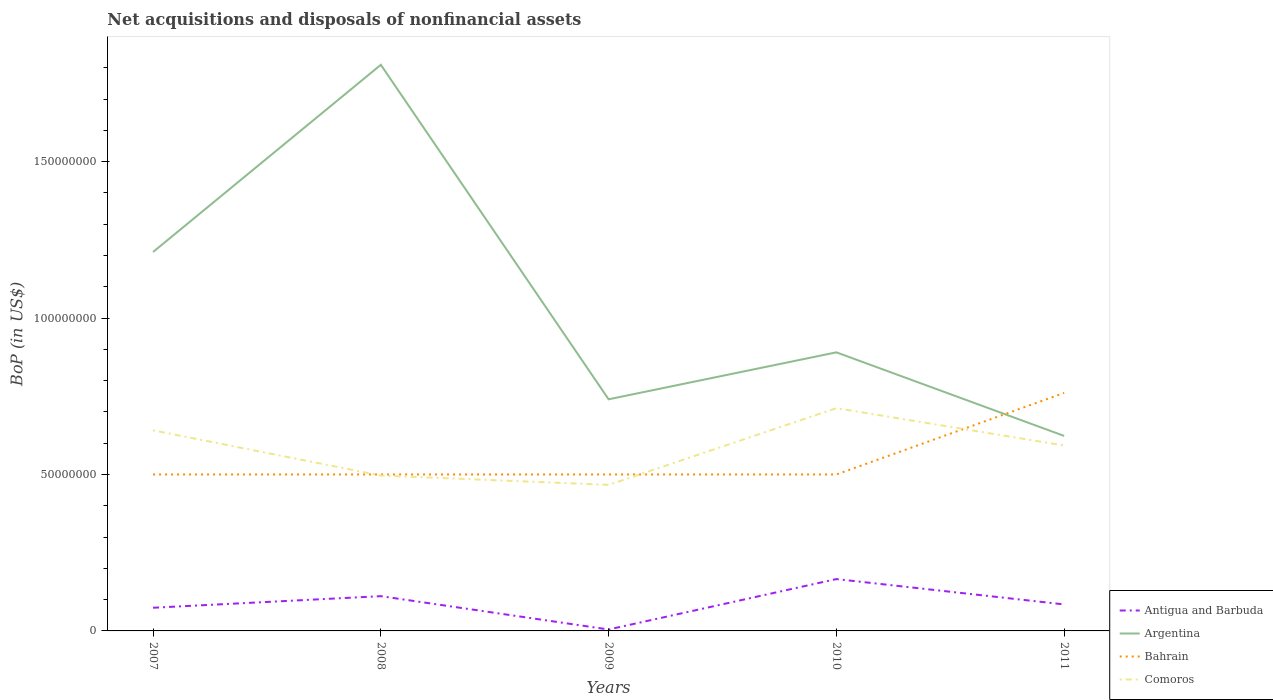How many different coloured lines are there?
Offer a terse response. 4. Does the line corresponding to Bahrain intersect with the line corresponding to Antigua and Barbuda?
Make the answer very short. No. Across all years, what is the maximum Balance of Payments in Comoros?
Keep it short and to the point. 4.67e+07. What is the total Balance of Payments in Argentina in the graph?
Keep it short and to the point. 3.21e+07. What is the difference between the highest and the second highest Balance of Payments in Bahrain?
Offer a terse response. 2.61e+07. Is the Balance of Payments in Antigua and Barbuda strictly greater than the Balance of Payments in Comoros over the years?
Ensure brevity in your answer.  Yes. How many lines are there?
Ensure brevity in your answer.  4. Are the values on the major ticks of Y-axis written in scientific E-notation?
Ensure brevity in your answer.  No. Does the graph contain any zero values?
Provide a short and direct response. No. Where does the legend appear in the graph?
Your answer should be compact. Bottom right. What is the title of the graph?
Offer a very short reply. Net acquisitions and disposals of nonfinancial assets. Does "Lao PDR" appear as one of the legend labels in the graph?
Your answer should be compact. No. What is the label or title of the X-axis?
Your response must be concise. Years. What is the label or title of the Y-axis?
Provide a succinct answer. BoP (in US$). What is the BoP (in US$) in Antigua and Barbuda in 2007?
Keep it short and to the point. 7.41e+06. What is the BoP (in US$) in Argentina in 2007?
Offer a very short reply. 1.21e+08. What is the BoP (in US$) of Bahrain in 2007?
Ensure brevity in your answer.  5.00e+07. What is the BoP (in US$) of Comoros in 2007?
Your answer should be compact. 6.41e+07. What is the BoP (in US$) of Antigua and Barbuda in 2008?
Your answer should be compact. 1.11e+07. What is the BoP (in US$) in Argentina in 2008?
Your answer should be very brief. 1.81e+08. What is the BoP (in US$) of Bahrain in 2008?
Provide a succinct answer. 5.00e+07. What is the BoP (in US$) in Comoros in 2008?
Provide a succinct answer. 4.97e+07. What is the BoP (in US$) in Antigua and Barbuda in 2009?
Make the answer very short. 4.59e+05. What is the BoP (in US$) of Argentina in 2009?
Offer a terse response. 7.40e+07. What is the BoP (in US$) in Comoros in 2009?
Your answer should be very brief. 4.67e+07. What is the BoP (in US$) in Antigua and Barbuda in 2010?
Make the answer very short. 1.66e+07. What is the BoP (in US$) in Argentina in 2010?
Provide a succinct answer. 8.90e+07. What is the BoP (in US$) in Comoros in 2010?
Give a very brief answer. 7.12e+07. What is the BoP (in US$) in Antigua and Barbuda in 2011?
Your answer should be compact. 8.47e+06. What is the BoP (in US$) of Argentina in 2011?
Keep it short and to the point. 6.23e+07. What is the BoP (in US$) in Bahrain in 2011?
Ensure brevity in your answer.  7.61e+07. What is the BoP (in US$) of Comoros in 2011?
Your response must be concise. 5.93e+07. Across all years, what is the maximum BoP (in US$) in Antigua and Barbuda?
Your response must be concise. 1.66e+07. Across all years, what is the maximum BoP (in US$) in Argentina?
Keep it short and to the point. 1.81e+08. Across all years, what is the maximum BoP (in US$) of Bahrain?
Your response must be concise. 7.61e+07. Across all years, what is the maximum BoP (in US$) in Comoros?
Give a very brief answer. 7.12e+07. Across all years, what is the minimum BoP (in US$) of Antigua and Barbuda?
Give a very brief answer. 4.59e+05. Across all years, what is the minimum BoP (in US$) of Argentina?
Keep it short and to the point. 6.23e+07. Across all years, what is the minimum BoP (in US$) in Comoros?
Your answer should be very brief. 4.67e+07. What is the total BoP (in US$) of Antigua and Barbuda in the graph?
Offer a terse response. 4.40e+07. What is the total BoP (in US$) in Argentina in the graph?
Offer a very short reply. 5.27e+08. What is the total BoP (in US$) of Bahrain in the graph?
Your response must be concise. 2.76e+08. What is the total BoP (in US$) in Comoros in the graph?
Your response must be concise. 2.91e+08. What is the difference between the BoP (in US$) of Antigua and Barbuda in 2007 and that in 2008?
Give a very brief answer. -3.70e+06. What is the difference between the BoP (in US$) of Argentina in 2007 and that in 2008?
Ensure brevity in your answer.  -5.98e+07. What is the difference between the BoP (in US$) in Bahrain in 2007 and that in 2008?
Your answer should be very brief. 0. What is the difference between the BoP (in US$) in Comoros in 2007 and that in 2008?
Keep it short and to the point. 1.45e+07. What is the difference between the BoP (in US$) in Antigua and Barbuda in 2007 and that in 2009?
Keep it short and to the point. 6.95e+06. What is the difference between the BoP (in US$) in Argentina in 2007 and that in 2009?
Your response must be concise. 4.71e+07. What is the difference between the BoP (in US$) of Bahrain in 2007 and that in 2009?
Provide a succinct answer. 0. What is the difference between the BoP (in US$) of Comoros in 2007 and that in 2009?
Give a very brief answer. 1.74e+07. What is the difference between the BoP (in US$) of Antigua and Barbuda in 2007 and that in 2010?
Your response must be concise. -9.16e+06. What is the difference between the BoP (in US$) in Argentina in 2007 and that in 2010?
Your response must be concise. 3.21e+07. What is the difference between the BoP (in US$) of Comoros in 2007 and that in 2010?
Make the answer very short. -7.08e+06. What is the difference between the BoP (in US$) in Antigua and Barbuda in 2007 and that in 2011?
Offer a very short reply. -1.06e+06. What is the difference between the BoP (in US$) of Argentina in 2007 and that in 2011?
Ensure brevity in your answer.  5.88e+07. What is the difference between the BoP (in US$) of Bahrain in 2007 and that in 2011?
Provide a short and direct response. -2.61e+07. What is the difference between the BoP (in US$) of Comoros in 2007 and that in 2011?
Give a very brief answer. 4.85e+06. What is the difference between the BoP (in US$) of Antigua and Barbuda in 2008 and that in 2009?
Offer a terse response. 1.07e+07. What is the difference between the BoP (in US$) of Argentina in 2008 and that in 2009?
Provide a short and direct response. 1.07e+08. What is the difference between the BoP (in US$) of Bahrain in 2008 and that in 2009?
Keep it short and to the point. 0. What is the difference between the BoP (in US$) in Comoros in 2008 and that in 2009?
Provide a short and direct response. 2.97e+06. What is the difference between the BoP (in US$) of Antigua and Barbuda in 2008 and that in 2010?
Offer a very short reply. -5.46e+06. What is the difference between the BoP (in US$) in Argentina in 2008 and that in 2010?
Offer a terse response. 9.19e+07. What is the difference between the BoP (in US$) of Comoros in 2008 and that in 2010?
Keep it short and to the point. -2.15e+07. What is the difference between the BoP (in US$) in Antigua and Barbuda in 2008 and that in 2011?
Make the answer very short. 2.64e+06. What is the difference between the BoP (in US$) in Argentina in 2008 and that in 2011?
Ensure brevity in your answer.  1.19e+08. What is the difference between the BoP (in US$) in Bahrain in 2008 and that in 2011?
Ensure brevity in your answer.  -2.61e+07. What is the difference between the BoP (in US$) of Comoros in 2008 and that in 2011?
Your answer should be compact. -9.60e+06. What is the difference between the BoP (in US$) in Antigua and Barbuda in 2009 and that in 2010?
Offer a very short reply. -1.61e+07. What is the difference between the BoP (in US$) in Argentina in 2009 and that in 2010?
Provide a short and direct response. -1.50e+07. What is the difference between the BoP (in US$) of Bahrain in 2009 and that in 2010?
Provide a short and direct response. 0. What is the difference between the BoP (in US$) of Comoros in 2009 and that in 2010?
Ensure brevity in your answer.  -2.45e+07. What is the difference between the BoP (in US$) of Antigua and Barbuda in 2009 and that in 2011?
Your answer should be very brief. -8.01e+06. What is the difference between the BoP (in US$) in Argentina in 2009 and that in 2011?
Provide a succinct answer. 1.17e+07. What is the difference between the BoP (in US$) in Bahrain in 2009 and that in 2011?
Keep it short and to the point. -2.61e+07. What is the difference between the BoP (in US$) of Comoros in 2009 and that in 2011?
Provide a short and direct response. -1.26e+07. What is the difference between the BoP (in US$) in Antigua and Barbuda in 2010 and that in 2011?
Offer a very short reply. 8.10e+06. What is the difference between the BoP (in US$) of Argentina in 2010 and that in 2011?
Provide a succinct answer. 2.67e+07. What is the difference between the BoP (in US$) of Bahrain in 2010 and that in 2011?
Give a very brief answer. -2.61e+07. What is the difference between the BoP (in US$) of Comoros in 2010 and that in 2011?
Your response must be concise. 1.19e+07. What is the difference between the BoP (in US$) of Antigua and Barbuda in 2007 and the BoP (in US$) of Argentina in 2008?
Give a very brief answer. -1.74e+08. What is the difference between the BoP (in US$) in Antigua and Barbuda in 2007 and the BoP (in US$) in Bahrain in 2008?
Make the answer very short. -4.26e+07. What is the difference between the BoP (in US$) of Antigua and Barbuda in 2007 and the BoP (in US$) of Comoros in 2008?
Give a very brief answer. -4.22e+07. What is the difference between the BoP (in US$) of Argentina in 2007 and the BoP (in US$) of Bahrain in 2008?
Keep it short and to the point. 7.11e+07. What is the difference between the BoP (in US$) in Argentina in 2007 and the BoP (in US$) in Comoros in 2008?
Offer a terse response. 7.14e+07. What is the difference between the BoP (in US$) in Bahrain in 2007 and the BoP (in US$) in Comoros in 2008?
Your answer should be compact. 3.45e+05. What is the difference between the BoP (in US$) of Antigua and Barbuda in 2007 and the BoP (in US$) of Argentina in 2009?
Your answer should be compact. -6.66e+07. What is the difference between the BoP (in US$) of Antigua and Barbuda in 2007 and the BoP (in US$) of Bahrain in 2009?
Keep it short and to the point. -4.26e+07. What is the difference between the BoP (in US$) of Antigua and Barbuda in 2007 and the BoP (in US$) of Comoros in 2009?
Make the answer very short. -3.93e+07. What is the difference between the BoP (in US$) in Argentina in 2007 and the BoP (in US$) in Bahrain in 2009?
Give a very brief answer. 7.11e+07. What is the difference between the BoP (in US$) of Argentina in 2007 and the BoP (in US$) of Comoros in 2009?
Ensure brevity in your answer.  7.44e+07. What is the difference between the BoP (in US$) of Bahrain in 2007 and the BoP (in US$) of Comoros in 2009?
Make the answer very short. 3.32e+06. What is the difference between the BoP (in US$) in Antigua and Barbuda in 2007 and the BoP (in US$) in Argentina in 2010?
Provide a short and direct response. -8.16e+07. What is the difference between the BoP (in US$) in Antigua and Barbuda in 2007 and the BoP (in US$) in Bahrain in 2010?
Make the answer very short. -4.26e+07. What is the difference between the BoP (in US$) in Antigua and Barbuda in 2007 and the BoP (in US$) in Comoros in 2010?
Keep it short and to the point. -6.38e+07. What is the difference between the BoP (in US$) of Argentina in 2007 and the BoP (in US$) of Bahrain in 2010?
Provide a short and direct response. 7.11e+07. What is the difference between the BoP (in US$) in Argentina in 2007 and the BoP (in US$) in Comoros in 2010?
Keep it short and to the point. 4.99e+07. What is the difference between the BoP (in US$) in Bahrain in 2007 and the BoP (in US$) in Comoros in 2010?
Provide a succinct answer. -2.12e+07. What is the difference between the BoP (in US$) in Antigua and Barbuda in 2007 and the BoP (in US$) in Argentina in 2011?
Offer a very short reply. -5.49e+07. What is the difference between the BoP (in US$) in Antigua and Barbuda in 2007 and the BoP (in US$) in Bahrain in 2011?
Make the answer very short. -6.87e+07. What is the difference between the BoP (in US$) in Antigua and Barbuda in 2007 and the BoP (in US$) in Comoros in 2011?
Your answer should be very brief. -5.19e+07. What is the difference between the BoP (in US$) of Argentina in 2007 and the BoP (in US$) of Bahrain in 2011?
Make the answer very short. 4.50e+07. What is the difference between the BoP (in US$) of Argentina in 2007 and the BoP (in US$) of Comoros in 2011?
Provide a succinct answer. 6.18e+07. What is the difference between the BoP (in US$) in Bahrain in 2007 and the BoP (in US$) in Comoros in 2011?
Your response must be concise. -9.26e+06. What is the difference between the BoP (in US$) of Antigua and Barbuda in 2008 and the BoP (in US$) of Argentina in 2009?
Provide a short and direct response. -6.29e+07. What is the difference between the BoP (in US$) in Antigua and Barbuda in 2008 and the BoP (in US$) in Bahrain in 2009?
Provide a short and direct response. -3.89e+07. What is the difference between the BoP (in US$) of Antigua and Barbuda in 2008 and the BoP (in US$) of Comoros in 2009?
Keep it short and to the point. -3.56e+07. What is the difference between the BoP (in US$) in Argentina in 2008 and the BoP (in US$) in Bahrain in 2009?
Give a very brief answer. 1.31e+08. What is the difference between the BoP (in US$) in Argentina in 2008 and the BoP (in US$) in Comoros in 2009?
Your answer should be compact. 1.34e+08. What is the difference between the BoP (in US$) of Bahrain in 2008 and the BoP (in US$) of Comoros in 2009?
Give a very brief answer. 3.32e+06. What is the difference between the BoP (in US$) in Antigua and Barbuda in 2008 and the BoP (in US$) in Argentina in 2010?
Your response must be concise. -7.79e+07. What is the difference between the BoP (in US$) in Antigua and Barbuda in 2008 and the BoP (in US$) in Bahrain in 2010?
Offer a very short reply. -3.89e+07. What is the difference between the BoP (in US$) in Antigua and Barbuda in 2008 and the BoP (in US$) in Comoros in 2010?
Offer a terse response. -6.01e+07. What is the difference between the BoP (in US$) in Argentina in 2008 and the BoP (in US$) in Bahrain in 2010?
Offer a very short reply. 1.31e+08. What is the difference between the BoP (in US$) in Argentina in 2008 and the BoP (in US$) in Comoros in 2010?
Make the answer very short. 1.10e+08. What is the difference between the BoP (in US$) of Bahrain in 2008 and the BoP (in US$) of Comoros in 2010?
Give a very brief answer. -2.12e+07. What is the difference between the BoP (in US$) in Antigua and Barbuda in 2008 and the BoP (in US$) in Argentina in 2011?
Your response must be concise. -5.12e+07. What is the difference between the BoP (in US$) in Antigua and Barbuda in 2008 and the BoP (in US$) in Bahrain in 2011?
Make the answer very short. -6.50e+07. What is the difference between the BoP (in US$) of Antigua and Barbuda in 2008 and the BoP (in US$) of Comoros in 2011?
Give a very brief answer. -4.81e+07. What is the difference between the BoP (in US$) in Argentina in 2008 and the BoP (in US$) in Bahrain in 2011?
Provide a succinct answer. 1.05e+08. What is the difference between the BoP (in US$) of Argentina in 2008 and the BoP (in US$) of Comoros in 2011?
Give a very brief answer. 1.22e+08. What is the difference between the BoP (in US$) of Bahrain in 2008 and the BoP (in US$) of Comoros in 2011?
Keep it short and to the point. -9.26e+06. What is the difference between the BoP (in US$) of Antigua and Barbuda in 2009 and the BoP (in US$) of Argentina in 2010?
Provide a short and direct response. -8.86e+07. What is the difference between the BoP (in US$) in Antigua and Barbuda in 2009 and the BoP (in US$) in Bahrain in 2010?
Provide a succinct answer. -4.95e+07. What is the difference between the BoP (in US$) of Antigua and Barbuda in 2009 and the BoP (in US$) of Comoros in 2010?
Provide a succinct answer. -7.07e+07. What is the difference between the BoP (in US$) in Argentina in 2009 and the BoP (in US$) in Bahrain in 2010?
Give a very brief answer. 2.40e+07. What is the difference between the BoP (in US$) in Argentina in 2009 and the BoP (in US$) in Comoros in 2010?
Offer a terse response. 2.84e+06. What is the difference between the BoP (in US$) in Bahrain in 2009 and the BoP (in US$) in Comoros in 2010?
Your answer should be very brief. -2.12e+07. What is the difference between the BoP (in US$) in Antigua and Barbuda in 2009 and the BoP (in US$) in Argentina in 2011?
Provide a short and direct response. -6.19e+07. What is the difference between the BoP (in US$) of Antigua and Barbuda in 2009 and the BoP (in US$) of Bahrain in 2011?
Give a very brief answer. -7.56e+07. What is the difference between the BoP (in US$) in Antigua and Barbuda in 2009 and the BoP (in US$) in Comoros in 2011?
Your response must be concise. -5.88e+07. What is the difference between the BoP (in US$) of Argentina in 2009 and the BoP (in US$) of Bahrain in 2011?
Keep it short and to the point. -2.04e+06. What is the difference between the BoP (in US$) in Argentina in 2009 and the BoP (in US$) in Comoros in 2011?
Keep it short and to the point. 1.48e+07. What is the difference between the BoP (in US$) in Bahrain in 2009 and the BoP (in US$) in Comoros in 2011?
Your answer should be very brief. -9.26e+06. What is the difference between the BoP (in US$) in Antigua and Barbuda in 2010 and the BoP (in US$) in Argentina in 2011?
Keep it short and to the point. -4.58e+07. What is the difference between the BoP (in US$) in Antigua and Barbuda in 2010 and the BoP (in US$) in Bahrain in 2011?
Offer a very short reply. -5.95e+07. What is the difference between the BoP (in US$) in Antigua and Barbuda in 2010 and the BoP (in US$) in Comoros in 2011?
Offer a terse response. -4.27e+07. What is the difference between the BoP (in US$) in Argentina in 2010 and the BoP (in US$) in Bahrain in 2011?
Offer a terse response. 1.30e+07. What is the difference between the BoP (in US$) in Argentina in 2010 and the BoP (in US$) in Comoros in 2011?
Offer a very short reply. 2.98e+07. What is the difference between the BoP (in US$) in Bahrain in 2010 and the BoP (in US$) in Comoros in 2011?
Keep it short and to the point. -9.26e+06. What is the average BoP (in US$) in Antigua and Barbuda per year?
Offer a terse response. 8.80e+06. What is the average BoP (in US$) in Argentina per year?
Ensure brevity in your answer.  1.05e+08. What is the average BoP (in US$) of Bahrain per year?
Offer a very short reply. 5.52e+07. What is the average BoP (in US$) in Comoros per year?
Your answer should be very brief. 5.82e+07. In the year 2007, what is the difference between the BoP (in US$) of Antigua and Barbuda and BoP (in US$) of Argentina?
Offer a very short reply. -1.14e+08. In the year 2007, what is the difference between the BoP (in US$) in Antigua and Barbuda and BoP (in US$) in Bahrain?
Keep it short and to the point. -4.26e+07. In the year 2007, what is the difference between the BoP (in US$) of Antigua and Barbuda and BoP (in US$) of Comoros?
Make the answer very short. -5.67e+07. In the year 2007, what is the difference between the BoP (in US$) of Argentina and BoP (in US$) of Bahrain?
Keep it short and to the point. 7.11e+07. In the year 2007, what is the difference between the BoP (in US$) in Argentina and BoP (in US$) in Comoros?
Offer a very short reply. 5.70e+07. In the year 2007, what is the difference between the BoP (in US$) of Bahrain and BoP (in US$) of Comoros?
Ensure brevity in your answer.  -1.41e+07. In the year 2008, what is the difference between the BoP (in US$) of Antigua and Barbuda and BoP (in US$) of Argentina?
Ensure brevity in your answer.  -1.70e+08. In the year 2008, what is the difference between the BoP (in US$) in Antigua and Barbuda and BoP (in US$) in Bahrain?
Keep it short and to the point. -3.89e+07. In the year 2008, what is the difference between the BoP (in US$) in Antigua and Barbuda and BoP (in US$) in Comoros?
Provide a succinct answer. -3.85e+07. In the year 2008, what is the difference between the BoP (in US$) of Argentina and BoP (in US$) of Bahrain?
Make the answer very short. 1.31e+08. In the year 2008, what is the difference between the BoP (in US$) of Argentina and BoP (in US$) of Comoros?
Ensure brevity in your answer.  1.31e+08. In the year 2008, what is the difference between the BoP (in US$) of Bahrain and BoP (in US$) of Comoros?
Provide a short and direct response. 3.45e+05. In the year 2009, what is the difference between the BoP (in US$) in Antigua and Barbuda and BoP (in US$) in Argentina?
Offer a very short reply. -7.36e+07. In the year 2009, what is the difference between the BoP (in US$) of Antigua and Barbuda and BoP (in US$) of Bahrain?
Offer a terse response. -4.95e+07. In the year 2009, what is the difference between the BoP (in US$) in Antigua and Barbuda and BoP (in US$) in Comoros?
Ensure brevity in your answer.  -4.62e+07. In the year 2009, what is the difference between the BoP (in US$) in Argentina and BoP (in US$) in Bahrain?
Make the answer very short. 2.40e+07. In the year 2009, what is the difference between the BoP (in US$) of Argentina and BoP (in US$) of Comoros?
Keep it short and to the point. 2.73e+07. In the year 2009, what is the difference between the BoP (in US$) of Bahrain and BoP (in US$) of Comoros?
Provide a short and direct response. 3.32e+06. In the year 2010, what is the difference between the BoP (in US$) of Antigua and Barbuda and BoP (in US$) of Argentina?
Your answer should be very brief. -7.25e+07. In the year 2010, what is the difference between the BoP (in US$) of Antigua and Barbuda and BoP (in US$) of Bahrain?
Your answer should be compact. -3.34e+07. In the year 2010, what is the difference between the BoP (in US$) of Antigua and Barbuda and BoP (in US$) of Comoros?
Your response must be concise. -5.46e+07. In the year 2010, what is the difference between the BoP (in US$) in Argentina and BoP (in US$) in Bahrain?
Your answer should be very brief. 3.90e+07. In the year 2010, what is the difference between the BoP (in US$) in Argentina and BoP (in US$) in Comoros?
Your response must be concise. 1.78e+07. In the year 2010, what is the difference between the BoP (in US$) of Bahrain and BoP (in US$) of Comoros?
Provide a succinct answer. -2.12e+07. In the year 2011, what is the difference between the BoP (in US$) in Antigua and Barbuda and BoP (in US$) in Argentina?
Offer a very short reply. -5.39e+07. In the year 2011, what is the difference between the BoP (in US$) of Antigua and Barbuda and BoP (in US$) of Bahrain?
Offer a terse response. -6.76e+07. In the year 2011, what is the difference between the BoP (in US$) of Antigua and Barbuda and BoP (in US$) of Comoros?
Provide a short and direct response. -5.08e+07. In the year 2011, what is the difference between the BoP (in US$) of Argentina and BoP (in US$) of Bahrain?
Make the answer very short. -1.37e+07. In the year 2011, what is the difference between the BoP (in US$) of Argentina and BoP (in US$) of Comoros?
Your answer should be very brief. 3.06e+06. In the year 2011, what is the difference between the BoP (in US$) of Bahrain and BoP (in US$) of Comoros?
Offer a terse response. 1.68e+07. What is the ratio of the BoP (in US$) of Antigua and Barbuda in 2007 to that in 2008?
Make the answer very short. 0.67. What is the ratio of the BoP (in US$) of Argentina in 2007 to that in 2008?
Offer a very short reply. 0.67. What is the ratio of the BoP (in US$) of Comoros in 2007 to that in 2008?
Offer a terse response. 1.29. What is the ratio of the BoP (in US$) in Antigua and Barbuda in 2007 to that in 2009?
Your response must be concise. 16.13. What is the ratio of the BoP (in US$) in Argentina in 2007 to that in 2009?
Your answer should be very brief. 1.64. What is the ratio of the BoP (in US$) in Bahrain in 2007 to that in 2009?
Give a very brief answer. 1. What is the ratio of the BoP (in US$) of Comoros in 2007 to that in 2009?
Provide a succinct answer. 1.37. What is the ratio of the BoP (in US$) of Antigua and Barbuda in 2007 to that in 2010?
Provide a short and direct response. 0.45. What is the ratio of the BoP (in US$) in Argentina in 2007 to that in 2010?
Your answer should be compact. 1.36. What is the ratio of the BoP (in US$) of Bahrain in 2007 to that in 2010?
Offer a very short reply. 1. What is the ratio of the BoP (in US$) in Comoros in 2007 to that in 2010?
Keep it short and to the point. 0.9. What is the ratio of the BoP (in US$) of Antigua and Barbuda in 2007 to that in 2011?
Offer a terse response. 0.87. What is the ratio of the BoP (in US$) in Argentina in 2007 to that in 2011?
Make the answer very short. 1.94. What is the ratio of the BoP (in US$) of Bahrain in 2007 to that in 2011?
Provide a succinct answer. 0.66. What is the ratio of the BoP (in US$) of Comoros in 2007 to that in 2011?
Offer a very short reply. 1.08. What is the ratio of the BoP (in US$) of Antigua and Barbuda in 2008 to that in 2009?
Provide a succinct answer. 24.2. What is the ratio of the BoP (in US$) of Argentina in 2008 to that in 2009?
Give a very brief answer. 2.44. What is the ratio of the BoP (in US$) of Bahrain in 2008 to that in 2009?
Keep it short and to the point. 1. What is the ratio of the BoP (in US$) of Comoros in 2008 to that in 2009?
Provide a succinct answer. 1.06. What is the ratio of the BoP (in US$) of Antigua and Barbuda in 2008 to that in 2010?
Your answer should be very brief. 0.67. What is the ratio of the BoP (in US$) in Argentina in 2008 to that in 2010?
Give a very brief answer. 2.03. What is the ratio of the BoP (in US$) of Bahrain in 2008 to that in 2010?
Your answer should be very brief. 1. What is the ratio of the BoP (in US$) of Comoros in 2008 to that in 2010?
Your answer should be very brief. 0.7. What is the ratio of the BoP (in US$) in Antigua and Barbuda in 2008 to that in 2011?
Your response must be concise. 1.31. What is the ratio of the BoP (in US$) of Argentina in 2008 to that in 2011?
Provide a succinct answer. 2.9. What is the ratio of the BoP (in US$) in Bahrain in 2008 to that in 2011?
Provide a short and direct response. 0.66. What is the ratio of the BoP (in US$) in Comoros in 2008 to that in 2011?
Provide a short and direct response. 0.84. What is the ratio of the BoP (in US$) of Antigua and Barbuda in 2009 to that in 2010?
Keep it short and to the point. 0.03. What is the ratio of the BoP (in US$) in Argentina in 2009 to that in 2010?
Make the answer very short. 0.83. What is the ratio of the BoP (in US$) in Bahrain in 2009 to that in 2010?
Your response must be concise. 1. What is the ratio of the BoP (in US$) in Comoros in 2009 to that in 2010?
Your answer should be compact. 0.66. What is the ratio of the BoP (in US$) in Antigua and Barbuda in 2009 to that in 2011?
Give a very brief answer. 0.05. What is the ratio of the BoP (in US$) in Argentina in 2009 to that in 2011?
Your response must be concise. 1.19. What is the ratio of the BoP (in US$) in Bahrain in 2009 to that in 2011?
Offer a very short reply. 0.66. What is the ratio of the BoP (in US$) in Comoros in 2009 to that in 2011?
Offer a terse response. 0.79. What is the ratio of the BoP (in US$) in Antigua and Barbuda in 2010 to that in 2011?
Your response must be concise. 1.96. What is the ratio of the BoP (in US$) of Argentina in 2010 to that in 2011?
Keep it short and to the point. 1.43. What is the ratio of the BoP (in US$) of Bahrain in 2010 to that in 2011?
Offer a very short reply. 0.66. What is the ratio of the BoP (in US$) in Comoros in 2010 to that in 2011?
Provide a succinct answer. 1.2. What is the difference between the highest and the second highest BoP (in US$) in Antigua and Barbuda?
Your answer should be compact. 5.46e+06. What is the difference between the highest and the second highest BoP (in US$) in Argentina?
Your response must be concise. 5.98e+07. What is the difference between the highest and the second highest BoP (in US$) in Bahrain?
Your answer should be very brief. 2.61e+07. What is the difference between the highest and the second highest BoP (in US$) in Comoros?
Your answer should be very brief. 7.08e+06. What is the difference between the highest and the lowest BoP (in US$) of Antigua and Barbuda?
Offer a very short reply. 1.61e+07. What is the difference between the highest and the lowest BoP (in US$) of Argentina?
Make the answer very short. 1.19e+08. What is the difference between the highest and the lowest BoP (in US$) of Bahrain?
Offer a terse response. 2.61e+07. What is the difference between the highest and the lowest BoP (in US$) of Comoros?
Your answer should be very brief. 2.45e+07. 